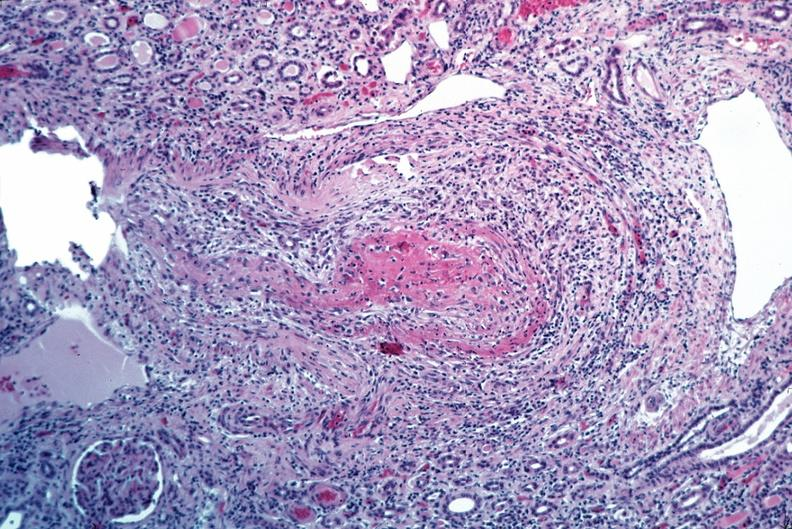where is this from?
Answer the question using a single word or phrase. Vasculature 